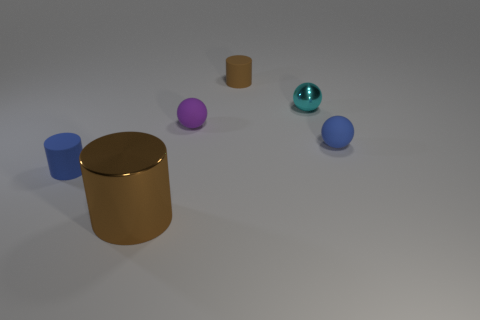Can you describe the arrangement of all the objects in the image? Certainly! In the image, we see a collection of objects on a flat surface. There's a large brown cylinder lying horizontally, with a small blue cylinder to its left and a violet sphere beside it. To the right of the brown cylinder, there's a teal sphere with a shiny surface, and a bit further to the right, there's a blue sphere. The lighting suggests an indoor setting, and the shadows are positioned to the objects' right, indicating the light source is to the left. 